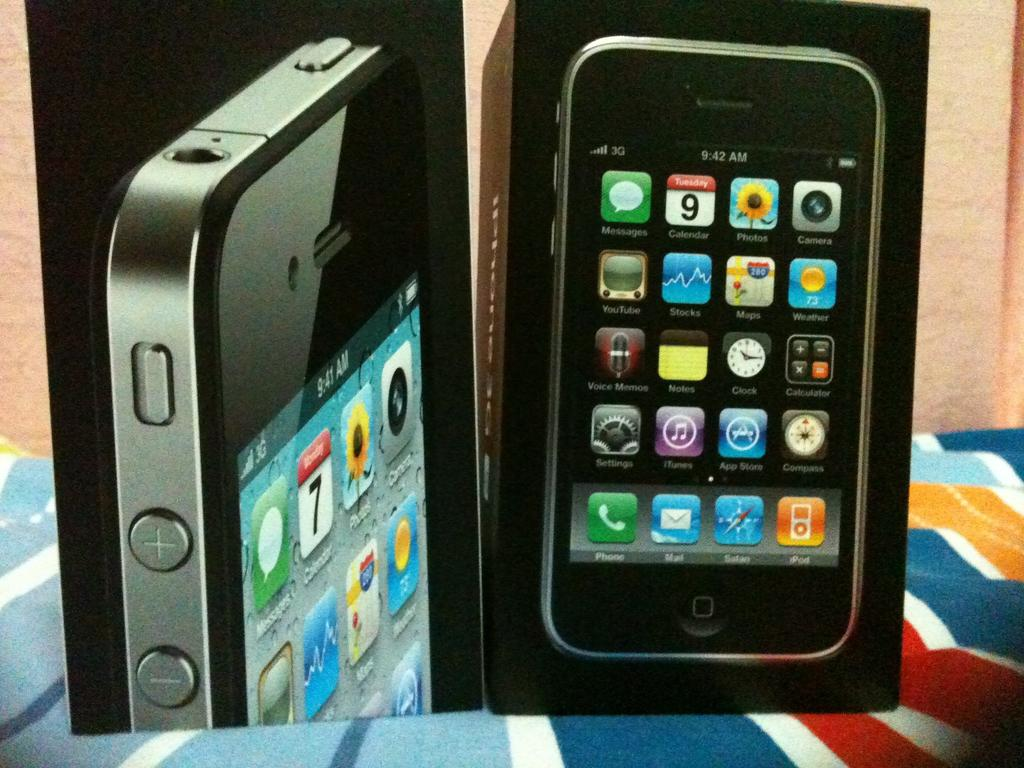What is the main subject of the image? The main subject of the image is boxes of mobiles. Where are the boxes of mobiles located? The boxes of mobiles are on an object. What type of camera can be seen in the image? There is no camera present in the image; it only features boxes of mobiles. 